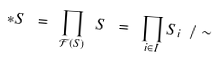<formula> <loc_0><loc_0><loc_500><loc_500>\ast S \ = \ \prod _ { \mathcal { F } ( S ) } \ S \ = \ \prod _ { i \in I } S _ { i } \ \slash \sim</formula> 